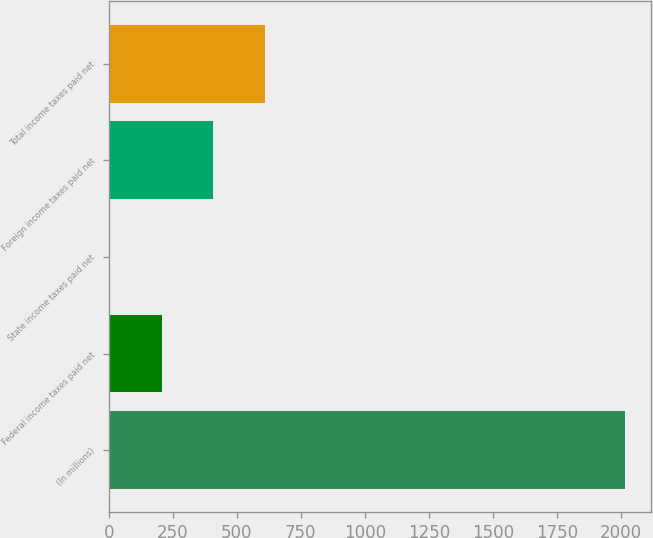Convert chart to OTSL. <chart><loc_0><loc_0><loc_500><loc_500><bar_chart><fcel>(In millions)<fcel>Federal income taxes paid net<fcel>State income taxes paid net<fcel>Foreign income taxes paid net<fcel>Total income taxes paid net<nl><fcel>2017<fcel>206.2<fcel>5<fcel>407.4<fcel>608.6<nl></chart> 